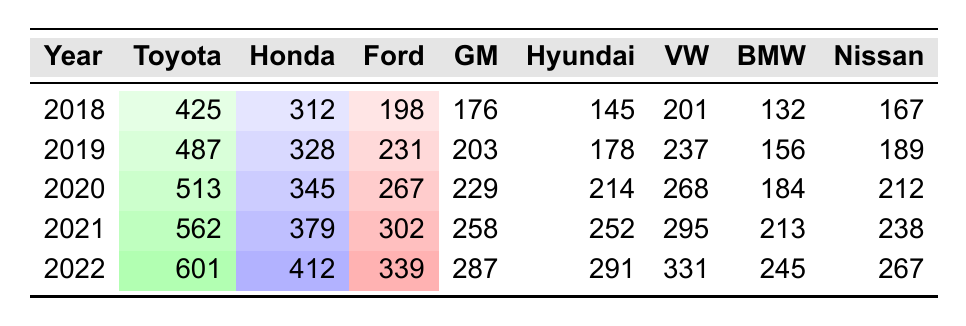What was the highest number of patents filed by Toyota, and in which year did this occur? The table shows that Toyota filed 601 patents in the year 2022, which is the highest number among all the years listed.
Answer: 601 patents in 2022 Which company had the least number of patents filed in 2018? Referring to the table, in 2018, Ford had the least number of patents filed with a total of 198.
Answer: Ford with 198 patents What is the total number of patents filed by Honda from 2018 to 2022? To find the total for Honda, we sum the filings: 312 + 328 + 345 + 379 + 412 = 1776.
Answer: 1776 patents Did BMW file more patents in 2021 than in 2020? According to the table, BMW filed 213 patents in 2021 and 184 in 2020, showing that filings in 2021 were indeed higher than in 2020.
Answer: Yes What was the percentage increase in patent filings for Hyundai from 2018 to 2022? Hyundai's patents in 2018 were 145 and in 2022 were 291. The increase is 291 - 145 = 146. To find the percentage increase, we use the formula: (146/145) * 100 = 100.69%.
Answer: 100.69% Which company had a consistent year-over-year increase in patent filings between 2018 and 2022? Reviewing the data, we see all companies showed an increase in filings each year, indicating that all had a consistent year-over-year increase.
Answer: All companies What was the average number of patents filed by General Motors over the five years? The total patents for General Motors are 176 + 203 + 229 + 258 + 287 = 1153. Dividing this by 5 gives an average of 230.6.
Answer: 230.6 In which year did Nissan have its highest patent filings? By examining the table, Nissan filed its highest number of patents in 2022, totaling 267.
Answer: 2022 What is the difference in patent filings between Volkswagen in 2021 and Honda in 2019? Volkswagen had 295 filings in 2021 and Honda had 328 in 2019. The difference is 328 - 295 = 33.
Answer: 33 How many more patents did Toyota file in 2021 compared to Ford in the same year? In 2021, Toyota filed 562 patents while Ford filed 302. The difference is 562 - 302 = 260 patents more from Toyota.
Answer: 260 patents 